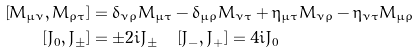<formula> <loc_0><loc_0><loc_500><loc_500>\left [ M _ { \mu \nu } , M _ { \rho \tau } \right ] & = \delta _ { \nu \rho } M _ { \mu \tau } - \delta _ { \mu \rho } M _ { \nu \tau } + \eta _ { \mu \tau } M _ { \nu \rho } - \eta _ { \nu \tau } M _ { \mu \rho } \\ \left [ J _ { 0 } , J _ { \pm } \right ] & = \pm 2 i J _ { \pm } \quad \left [ J _ { - } , J _ { + } \right ] = 4 i J _ { 0 }</formula> 